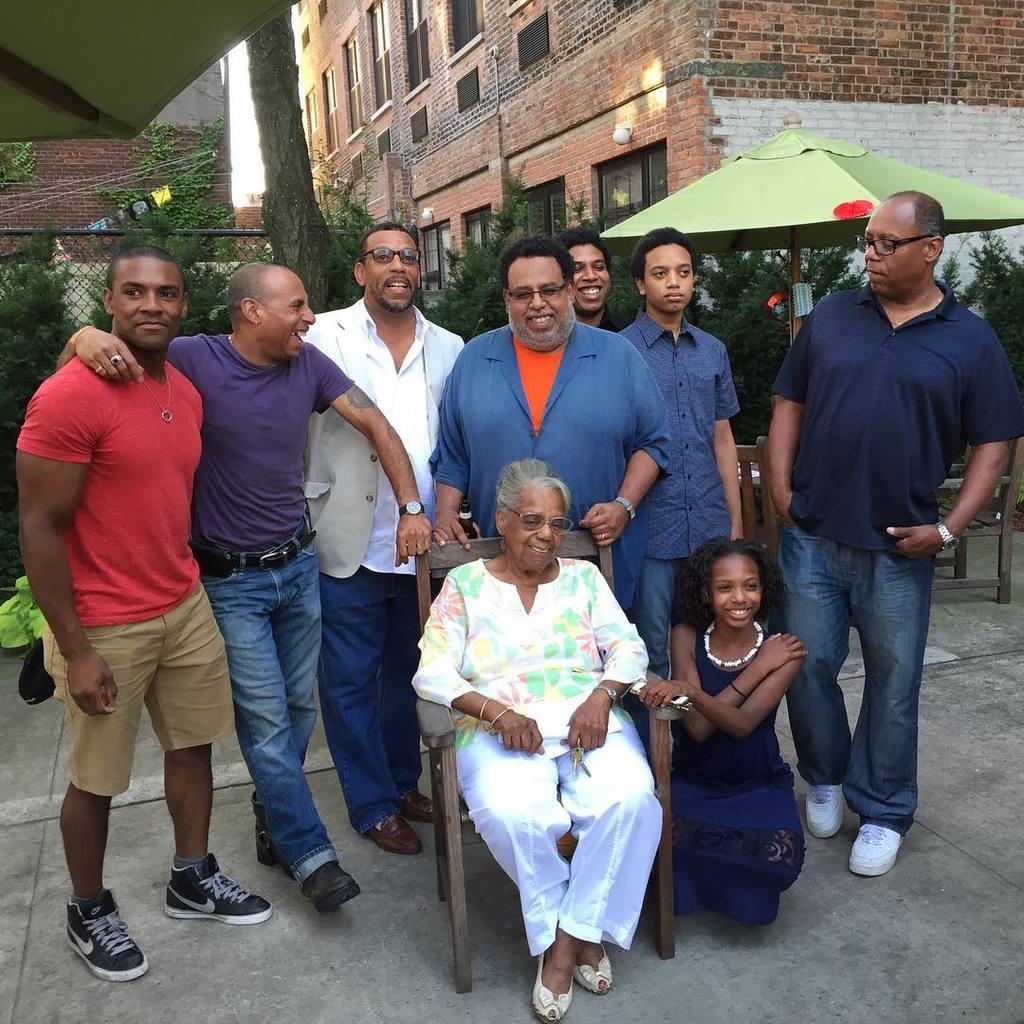How would you summarize this image in a sentence or two? In this image we can see some persons standing on the floor and some are sitting. In the background there are buildings, sky, trees, grills, parasol, plants, pipelines and floor. 